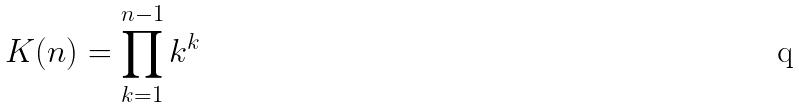<formula> <loc_0><loc_0><loc_500><loc_500>K ( n ) = \prod _ { k = 1 } ^ { n - 1 } k ^ { k }</formula> 